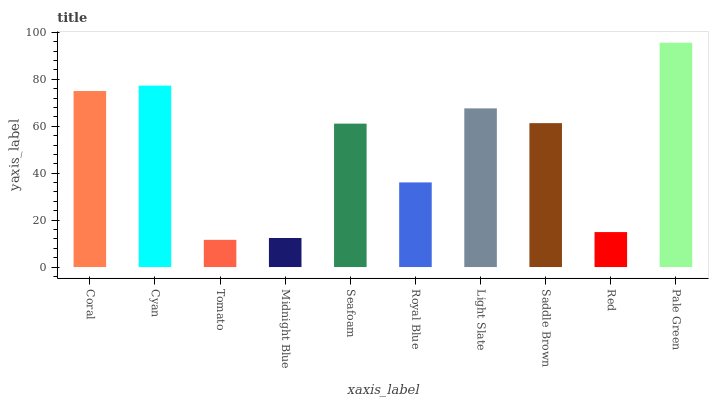Is Tomato the minimum?
Answer yes or no. Yes. Is Pale Green the maximum?
Answer yes or no. Yes. Is Cyan the minimum?
Answer yes or no. No. Is Cyan the maximum?
Answer yes or no. No. Is Cyan greater than Coral?
Answer yes or no. Yes. Is Coral less than Cyan?
Answer yes or no. Yes. Is Coral greater than Cyan?
Answer yes or no. No. Is Cyan less than Coral?
Answer yes or no. No. Is Saddle Brown the high median?
Answer yes or no. Yes. Is Seafoam the low median?
Answer yes or no. Yes. Is Tomato the high median?
Answer yes or no. No. Is Coral the low median?
Answer yes or no. No. 